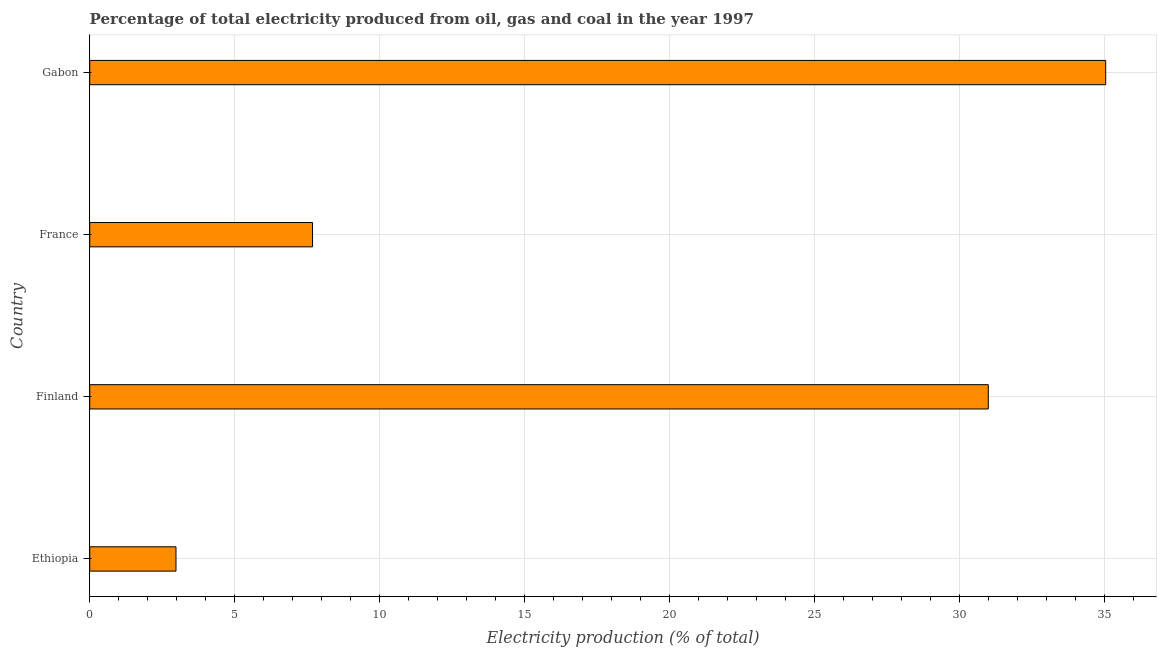Does the graph contain any zero values?
Your answer should be compact. No. What is the title of the graph?
Provide a short and direct response. Percentage of total electricity produced from oil, gas and coal in the year 1997. What is the label or title of the X-axis?
Your response must be concise. Electricity production (% of total). What is the electricity production in Ethiopia?
Keep it short and to the point. 2.97. Across all countries, what is the maximum electricity production?
Offer a very short reply. 35.03. Across all countries, what is the minimum electricity production?
Your response must be concise. 2.97. In which country was the electricity production maximum?
Keep it short and to the point. Gabon. In which country was the electricity production minimum?
Provide a succinct answer. Ethiopia. What is the sum of the electricity production?
Your response must be concise. 76.67. What is the difference between the electricity production in Finland and Gabon?
Give a very brief answer. -4.05. What is the average electricity production per country?
Offer a terse response. 19.17. What is the median electricity production?
Offer a very short reply. 19.33. In how many countries, is the electricity production greater than 5 %?
Offer a very short reply. 3. What is the ratio of the electricity production in France to that in Gabon?
Give a very brief answer. 0.22. What is the difference between the highest and the second highest electricity production?
Offer a terse response. 4.05. What is the difference between the highest and the lowest electricity production?
Your answer should be compact. 32.06. In how many countries, is the electricity production greater than the average electricity production taken over all countries?
Make the answer very short. 2. How many bars are there?
Give a very brief answer. 4. Are all the bars in the graph horizontal?
Your answer should be very brief. Yes. How many countries are there in the graph?
Your answer should be very brief. 4. Are the values on the major ticks of X-axis written in scientific E-notation?
Your response must be concise. No. What is the Electricity production (% of total) of Ethiopia?
Offer a terse response. 2.97. What is the Electricity production (% of total) in Finland?
Offer a terse response. 30.98. What is the Electricity production (% of total) of France?
Your response must be concise. 7.68. What is the Electricity production (% of total) of Gabon?
Your answer should be compact. 35.03. What is the difference between the Electricity production (% of total) in Ethiopia and Finland?
Provide a succinct answer. -28.01. What is the difference between the Electricity production (% of total) in Ethiopia and France?
Ensure brevity in your answer.  -4.71. What is the difference between the Electricity production (% of total) in Ethiopia and Gabon?
Your answer should be compact. -32.06. What is the difference between the Electricity production (% of total) in Finland and France?
Provide a short and direct response. 23.3. What is the difference between the Electricity production (% of total) in Finland and Gabon?
Provide a succinct answer. -4.05. What is the difference between the Electricity production (% of total) in France and Gabon?
Offer a very short reply. -27.35. What is the ratio of the Electricity production (% of total) in Ethiopia to that in Finland?
Give a very brief answer. 0.1. What is the ratio of the Electricity production (% of total) in Ethiopia to that in France?
Provide a succinct answer. 0.39. What is the ratio of the Electricity production (% of total) in Ethiopia to that in Gabon?
Ensure brevity in your answer.  0.09. What is the ratio of the Electricity production (% of total) in Finland to that in France?
Your response must be concise. 4.03. What is the ratio of the Electricity production (% of total) in Finland to that in Gabon?
Provide a succinct answer. 0.88. What is the ratio of the Electricity production (% of total) in France to that in Gabon?
Offer a very short reply. 0.22. 